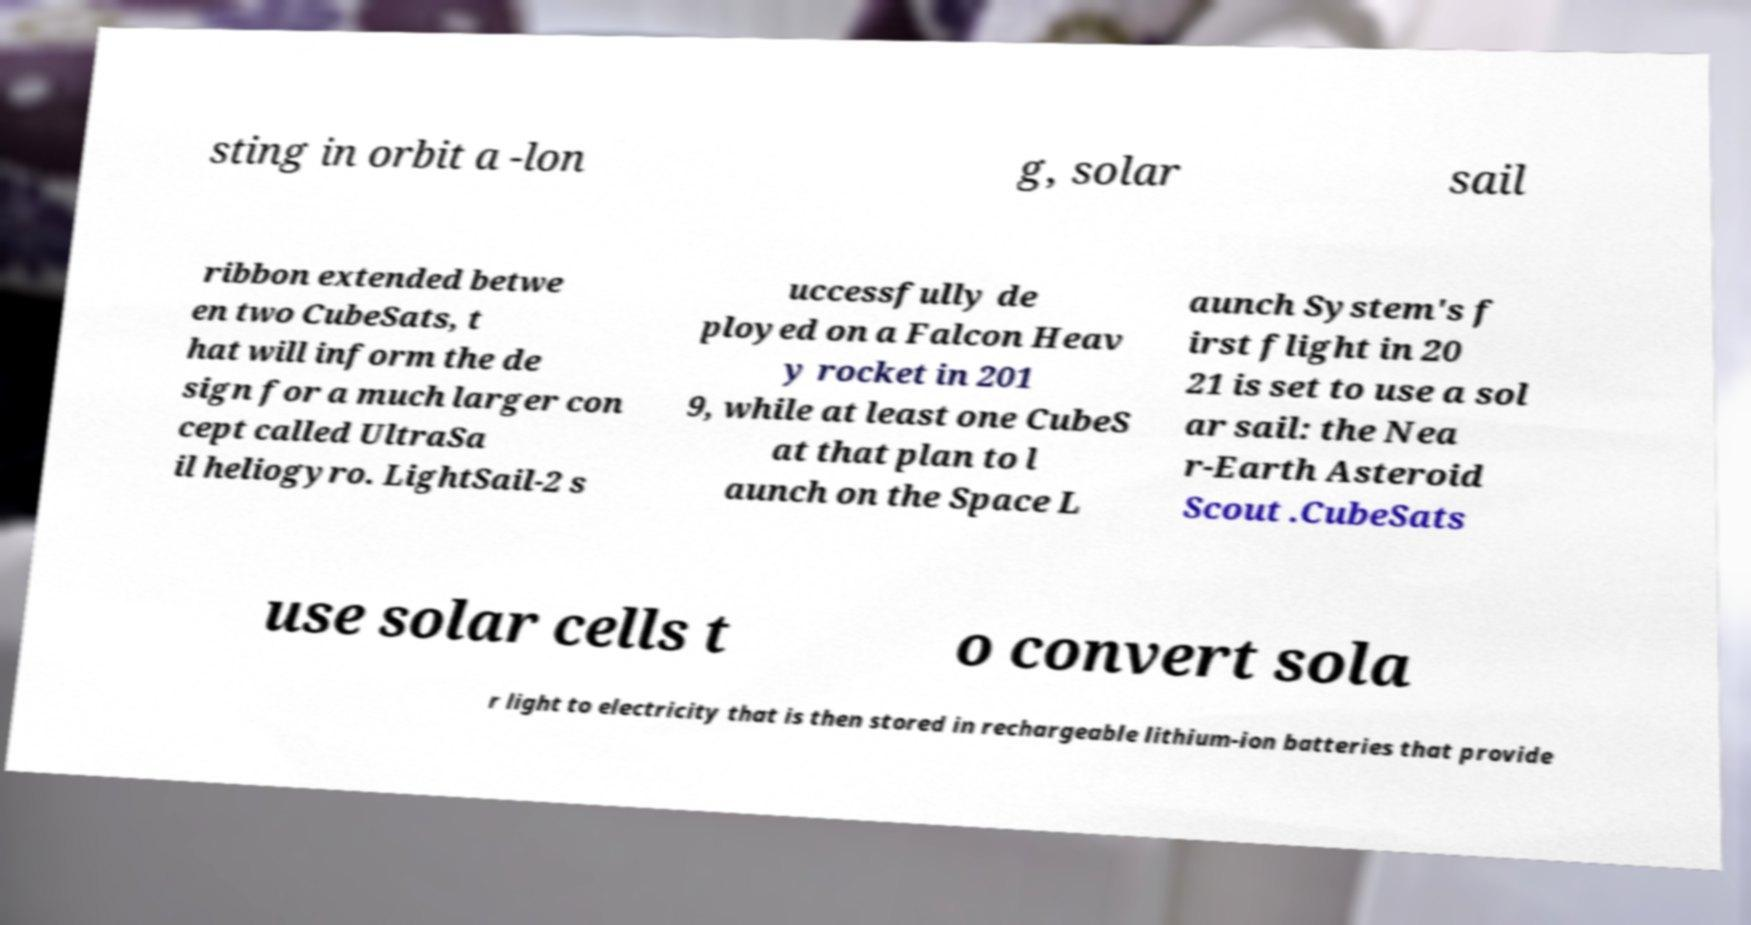I need the written content from this picture converted into text. Can you do that? sting in orbit a -lon g, solar sail ribbon extended betwe en two CubeSats, t hat will inform the de sign for a much larger con cept called UltraSa il heliogyro. LightSail-2 s uccessfully de ployed on a Falcon Heav y rocket in 201 9, while at least one CubeS at that plan to l aunch on the Space L aunch System's f irst flight in 20 21 is set to use a sol ar sail: the Nea r-Earth Asteroid Scout .CubeSats use solar cells t o convert sola r light to electricity that is then stored in rechargeable lithium-ion batteries that provide 